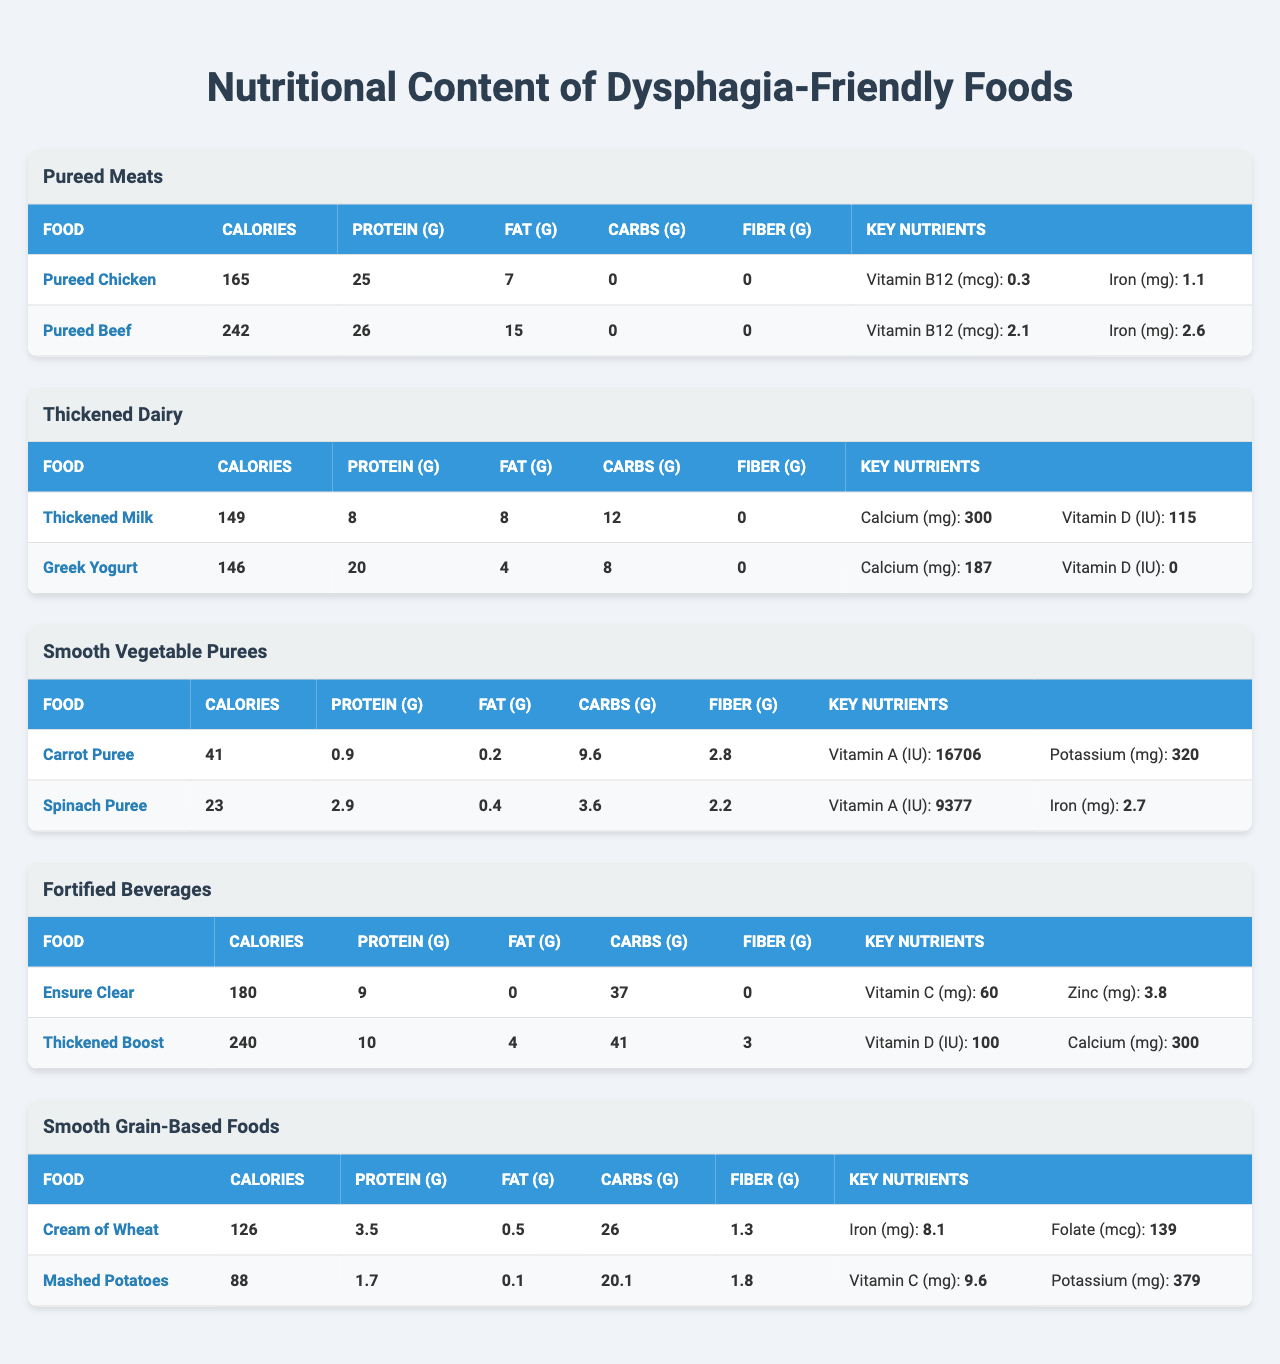What is the calorie content of Pureed Chicken? The table lists Pureed Chicken under the "Pureed Meats" category, and the calorie content is specified as 165 calories.
Answer: 165 calories Which food has the highest protein content? By examining the protein values in the table, Pureed Beef has 26 grams of protein, which is the highest compared to other foods listed.
Answer: Pureed Beef How much fat is in Thickened Milk? Thickened Milk's nutritional information indicates it contains 8 grams of fat, as shown in the table.
Answer: 8 grams What is the total carbohydrate content of Cream of Wheat and Mashed Potatoes? The carbohydrate content for Cream of Wheat is 26 grams and for Mashed Potatoes is 20.1 grams. Adding these values gives 26 + 20.1 = 46.1 grams.
Answer: 46.1 grams Is Greek Yogurt higher in protein or fat? Greek Yogurt contains 20 grams of protein and 4 grams of fat. Since 20 is greater than 4, Greek Yogurt has more protein than fat.
Answer: Yes, higher in protein What is the difference in calorie content between Thickened Boost and Ensure Clear? Thickened Boost has 240 calories and Ensure Clear has 180 calories. The difference is 240 - 180 = 60 calories.
Answer: 60 calories Which food has the highest carbohydrate content among the Smooth Vegetable Purees? Among Carrot Puree and Spinach Puree, Carrot Puree has 9.6 grams of carbohydrates, while Spinach Puree has 3.6 grams. Therefore, Carrot Puree has the highest carbohydrate content.
Answer: Carrot Puree If you wanted to increase your calcium intake using the Thickened Dairy category, which food would you choose? Thickened Milk provides 300 mg of calcium, whereas Greek Yogurt offers only 187 mg. Thus, to maximize calcium intake, one should choose Thickened Milk.
Answer: Thickened Milk What is the average fat content of the Pureed Meats category? Pureed Chicken has 7 grams of fat and Pureed Beef has 15 grams. The average fat content is (7 + 15) / 2 = 11 grams.
Answer: 11 grams Which Smooth Grain-Based Food has more fiber content? Cream of Wheat contains 1.3 grams of fiber while Mashed Potatoes have 1.8 grams. To determine which one has more fiber, we see Mashed Potatoes has the higher amount.
Answer: Mashed Potatoes 